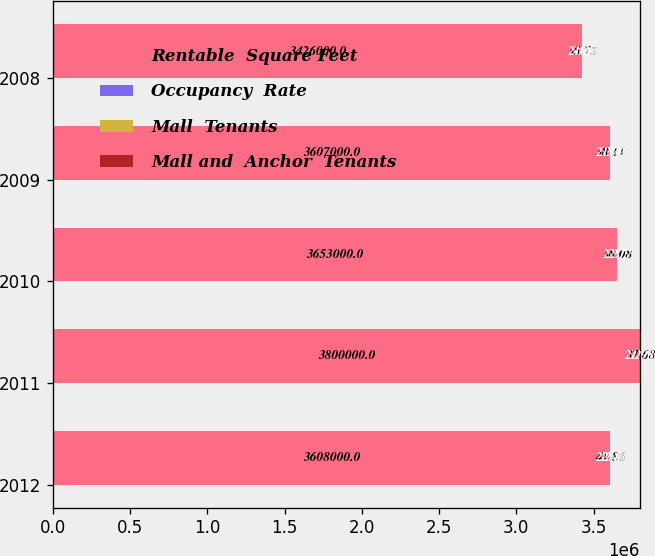Convert chart. <chart><loc_0><loc_0><loc_500><loc_500><stacked_bar_chart><ecel><fcel>2012<fcel>2011<fcel>2010<fcel>2009<fcel>2008<nl><fcel>Rentable  Square Feet<fcel>3.608e+06<fcel>3.8e+06<fcel>3.653e+06<fcel>3.607e+06<fcel>3.426e+06<nl><fcel>Occupancy  Rate<fcel>92.7<fcel>92.7<fcel>92.8<fcel>92.9<fcel>94.7<nl><fcel>Mall  Tenants<fcel>41.86<fcel>37.68<fcel>38.08<fcel>38.11<fcel>35.75<nl><fcel>Mall and  Anchor  Tenants<fcel>22.46<fcel>21.98<fcel>22.77<fcel>21.72<fcel>21.25<nl></chart> 